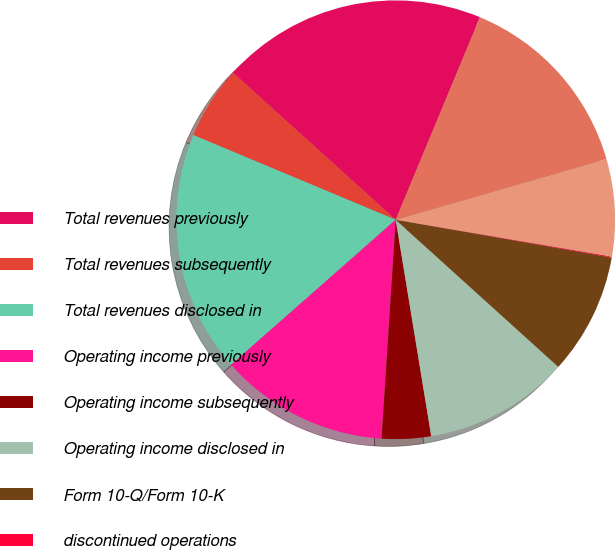<chart> <loc_0><loc_0><loc_500><loc_500><pie_chart><fcel>Total revenues previously<fcel>Total revenues subsequently<fcel>Total revenues disclosed in<fcel>Operating income previously<fcel>Operating income subsequently<fcel>Operating income disclosed in<fcel>Form 10-Q/Form 10-K<fcel>discontinued operations<fcel>Income (loss) from continuing<fcel>Discontinued operations net<nl><fcel>19.58%<fcel>5.39%<fcel>17.8%<fcel>12.48%<fcel>3.62%<fcel>10.71%<fcel>8.94%<fcel>0.07%<fcel>7.16%<fcel>14.26%<nl></chart> 